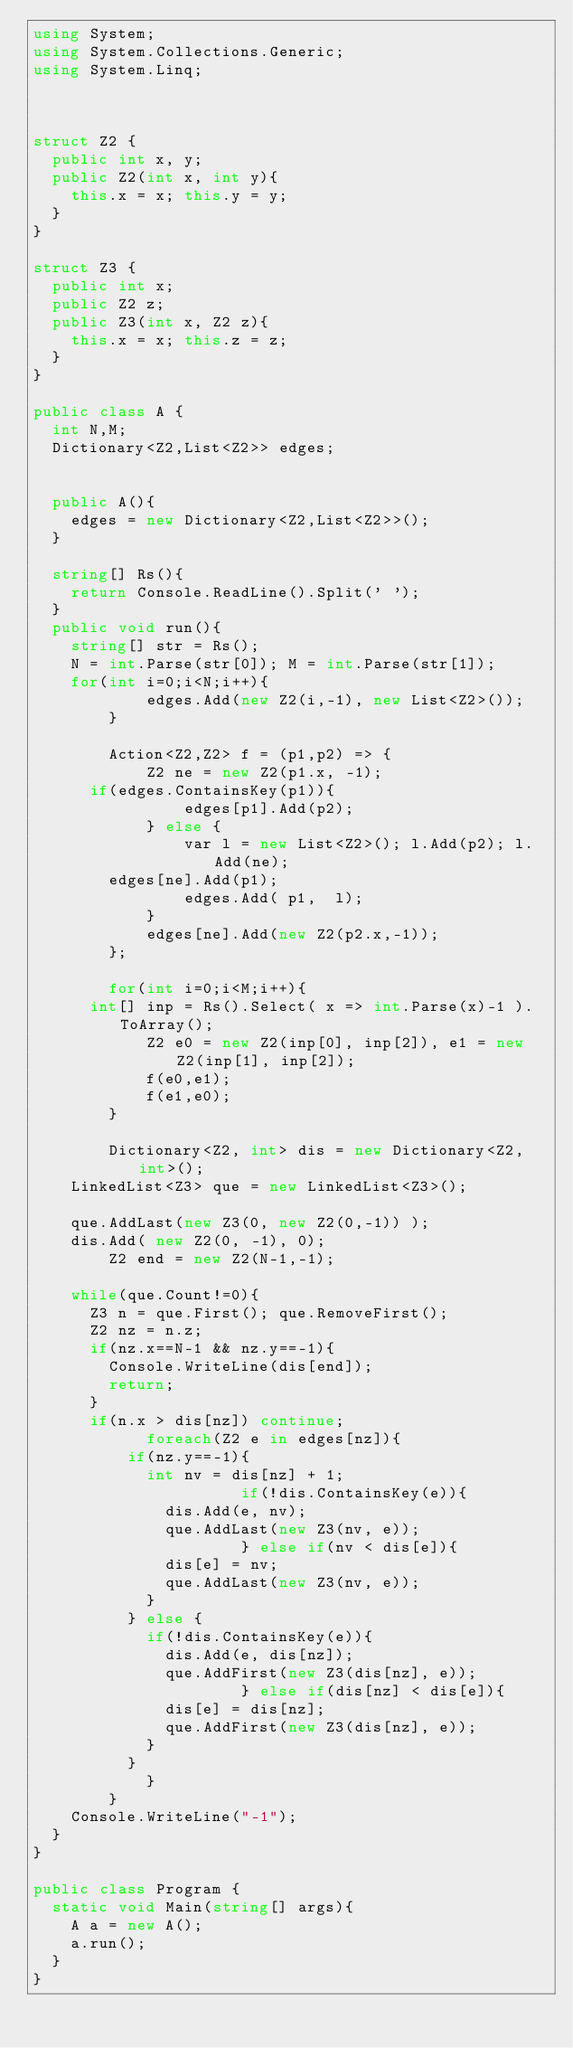<code> <loc_0><loc_0><loc_500><loc_500><_C#_>using System;
using System.Collections.Generic;
using System.Linq;


 
struct Z2 {
	public int x, y;
	public Z2(int x, int y){
		this.x = x; this.y = y;
	}
}

struct Z3 {
	public int x;
	public Z2 z;
	public Z3(int x, Z2 z){
		this.x = x; this.z = z;
	}
}
 
public class A {
	int N,M;
	Dictionary<Z2,List<Z2>> edges;
    
	
	public A(){
		edges = new Dictionary<Z2,List<Z2>>();
	}
	
	string[] Rs(){
		return Console.ReadLine().Split(' ');
	}
	public void run(){
		string[] str = Rs();
		N = int.Parse(str[0]); M = int.Parse(str[1]);
		for(int i=0;i<N;i++){
            edges.Add(new Z2(i,-1), new List<Z2>());
        }
        
        Action<Z2,Z2> f = (p1,p2) => {
            Z2 ne = new Z2(p1.x, -1);
			if(edges.ContainsKey(p1)){
                edges[p1].Add(p2);
            } else {
                var l = new List<Z2>(); l.Add(p2); l.Add(ne); 
				edges[ne].Add(p1);
                edges.Add( p1,  l);
            }
            edges[ne].Add(new Z2(p2.x,-1));
        };
        
        for(int i=0;i<M;i++){
			int[] inp = Rs().Select( x => int.Parse(x)-1 ).ToArray();
            Z2 e0 = new Z2(inp[0], inp[2]), e1 = new Z2(inp[1], inp[2]);
            f(e0,e1);
            f(e1,e0);
        }
        
        Dictionary<Z2, int> dis = new Dictionary<Z2,int>();
		LinkedList<Z3> que = new LinkedList<Z3>();
		
		que.AddLast(new Z3(0, new Z2(0,-1)) ); 
		dis.Add( new Z2(0, -1), 0);
        Z2 end = new Z2(N-1,-1);
        
		while(que.Count!=0){
			Z3 n = que.First(); que.RemoveFirst();
			Z2 nz = n.z;
			if(nz.x==N-1 && nz.y==-1){ 
				Console.WriteLine(dis[end]);
				return;
			}
			if(n.x > dis[nz]) continue;
            foreach(Z2 e in edges[nz]){
					if(nz.y==-1){
						int nv = dis[nz] + 1;
	                    if(!dis.ContainsKey(e)){
							dis.Add(e, nv);
							que.AddLast(new Z3(nv, e));
	                    } else if(nv < dis[e]){
							dis[e] = nv;
							que.AddLast(new Z3(nv, e));
						}
					} else {
						if(!dis.ContainsKey(e)){
							dis.Add(e, dis[nz]);
							que.AddFirst(new Z3(dis[nz], e));
	                    } else if(dis[nz] < dis[e]){
							dis[e] = dis[nz];
							que.AddFirst(new Z3(dis[nz], e));
						}
					}
            }
        }
		Console.WriteLine("-1");
	}
}
 
public class Program {
	static void Main(string[] args){
		A a = new A();
		a.run();
	}
}</code> 